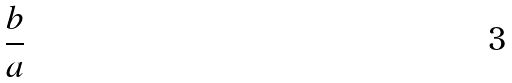<formula> <loc_0><loc_0><loc_500><loc_500>\frac { b } { a }</formula> 